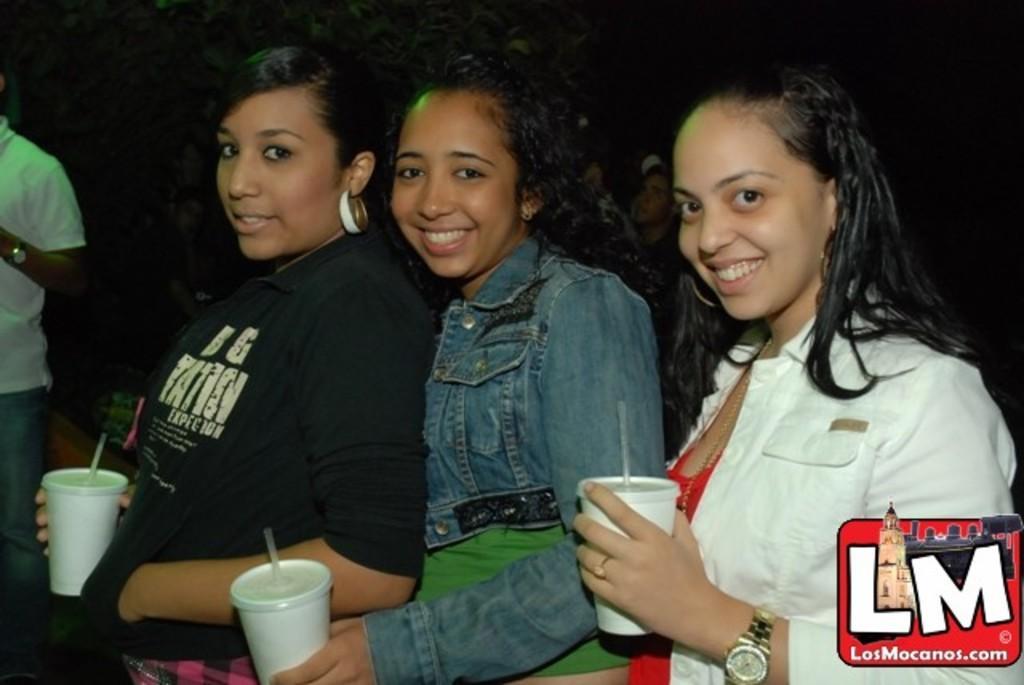Can you describe this image briefly? In this picture we can see three women, they are smiling and they are holding glasses and in the background we can see people, in the bottom right we can see a logo and some text. 